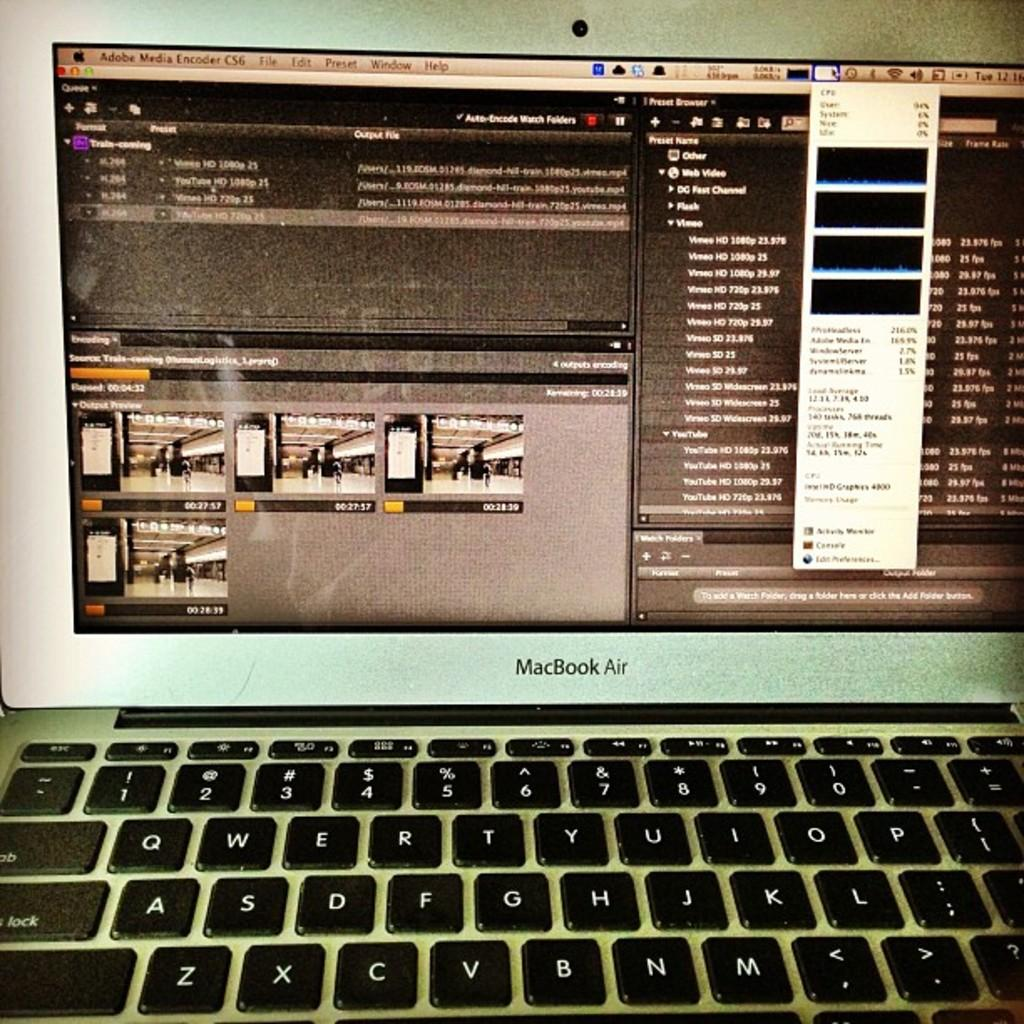<image>
Write a terse but informative summary of the picture. A MacBook Air laptop open to Adobe software 